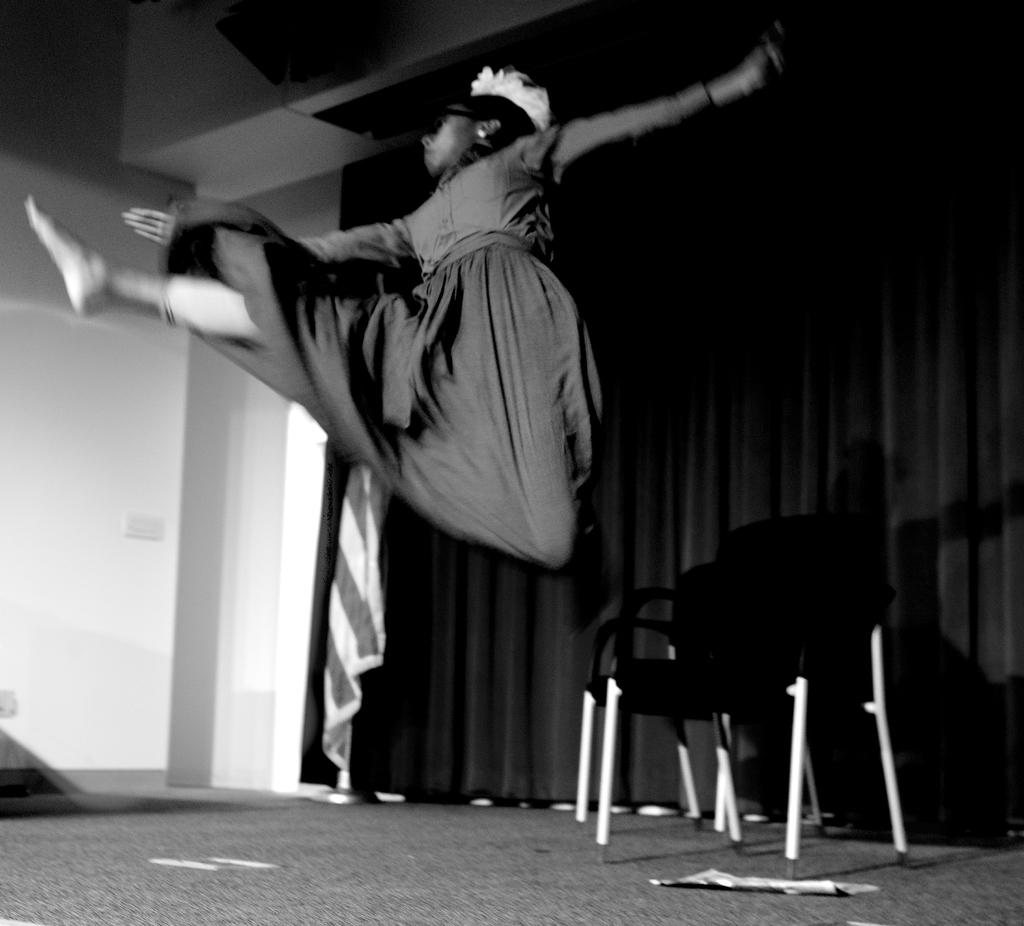What is the color scheme of the image? The image is black and white. Who is present in the image? There is a woman in the image. What type of furniture can be seen in the image? There is a group of chairs in the image. What is on the floor in the image? There are papers on the floor in the image. What type of window treatment is present in the image? There is a curtain in the image. What type of architectural feature is visible in the image? There is a wall in the image. What is the reaction of the cub to the men in the image? There is no cub or men present in the image, so this question cannot be answered. 